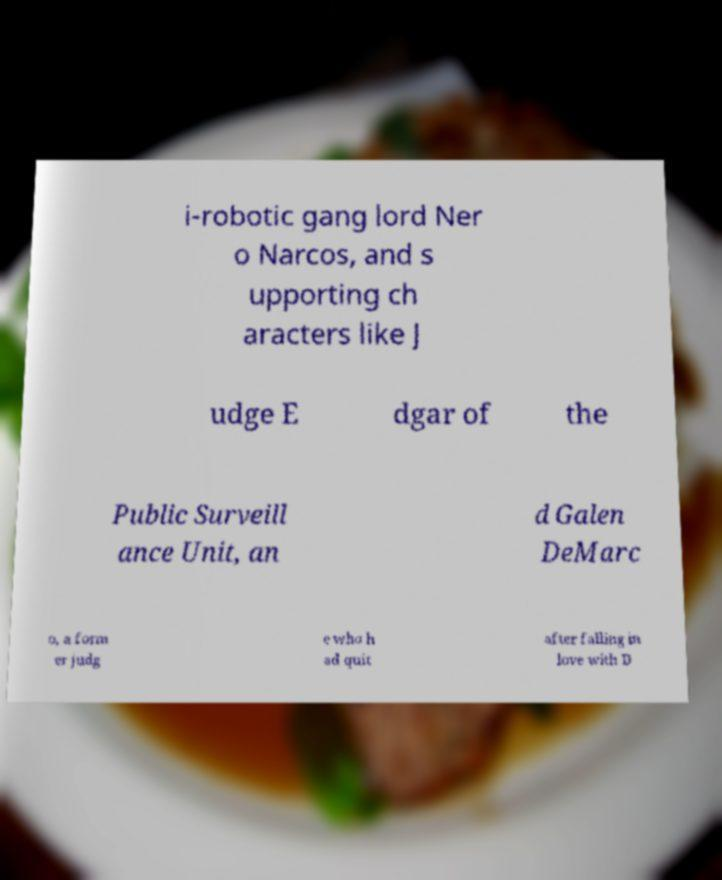Please read and relay the text visible in this image. What does it say? i-robotic gang lord Ner o Narcos, and s upporting ch aracters like J udge E dgar of the Public Surveill ance Unit, an d Galen DeMarc o, a form er judg e who h ad quit after falling in love with D 